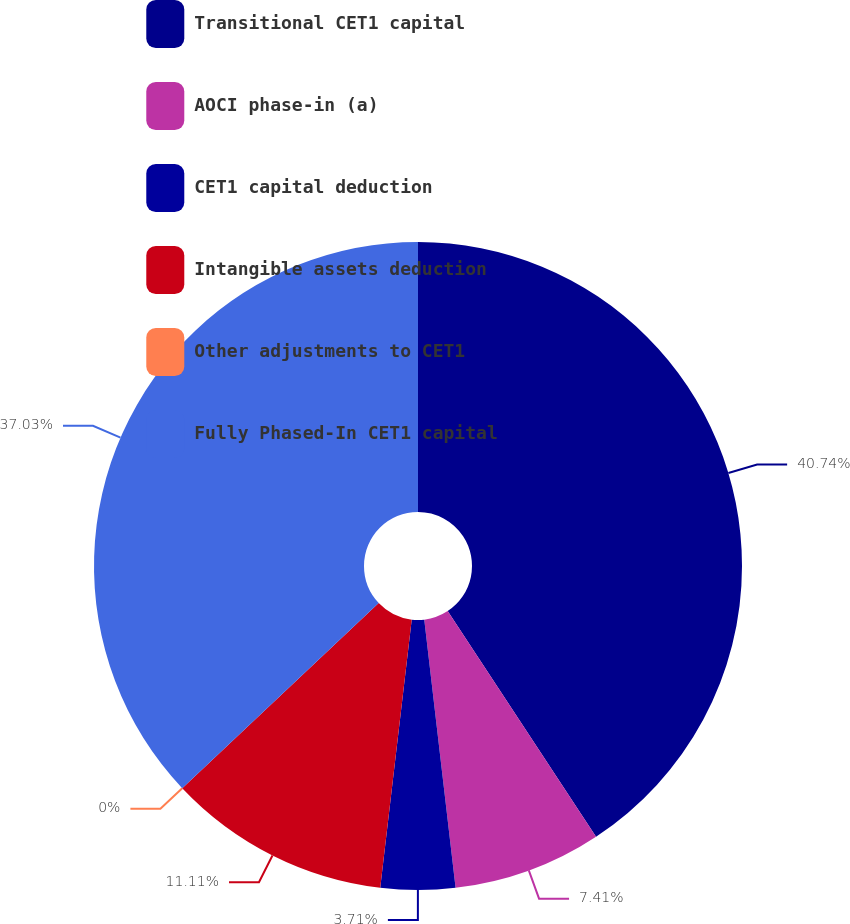Convert chart to OTSL. <chart><loc_0><loc_0><loc_500><loc_500><pie_chart><fcel>Transitional CET1 capital<fcel>AOCI phase-in (a)<fcel>CET1 capital deduction<fcel>Intangible assets deduction<fcel>Other adjustments to CET1<fcel>Fully Phased-In CET1 capital<nl><fcel>40.74%<fcel>7.41%<fcel>3.71%<fcel>11.11%<fcel>0.0%<fcel>37.03%<nl></chart> 